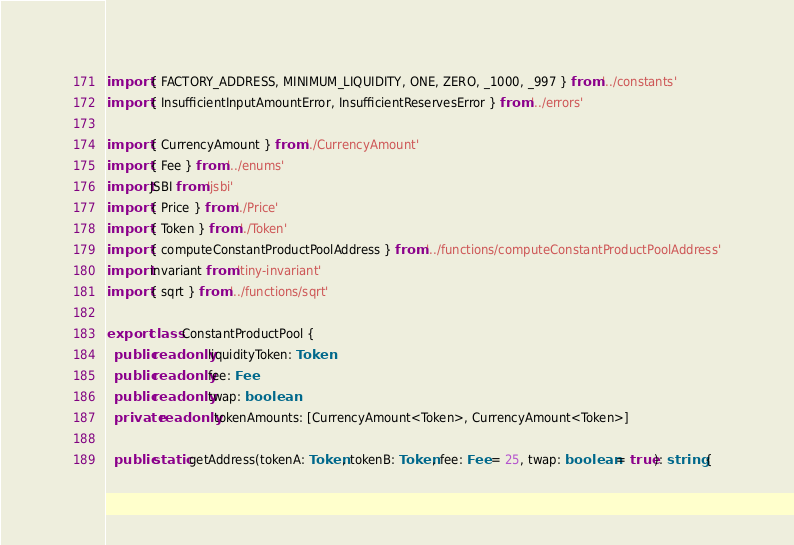<code> <loc_0><loc_0><loc_500><loc_500><_TypeScript_>import { FACTORY_ADDRESS, MINIMUM_LIQUIDITY, ONE, ZERO, _1000, _997 } from '../constants'
import { InsufficientInputAmountError, InsufficientReservesError } from '../errors'

import { CurrencyAmount } from './CurrencyAmount'
import { Fee } from '../enums'
import JSBI from 'jsbi'
import { Price } from './Price'
import { Token } from './Token'
import { computeConstantProductPoolAddress } from '../functions/computeConstantProductPoolAddress'
import invariant from 'tiny-invariant'
import { sqrt } from '../functions/sqrt'

export class ConstantProductPool {
  public readonly liquidityToken: Token
  public readonly fee: Fee
  public readonly twap: boolean
  private readonly tokenAmounts: [CurrencyAmount<Token>, CurrencyAmount<Token>]

  public static getAddress(tokenA: Token, tokenB: Token, fee: Fee = 25, twap: boolean = true): string {</code> 